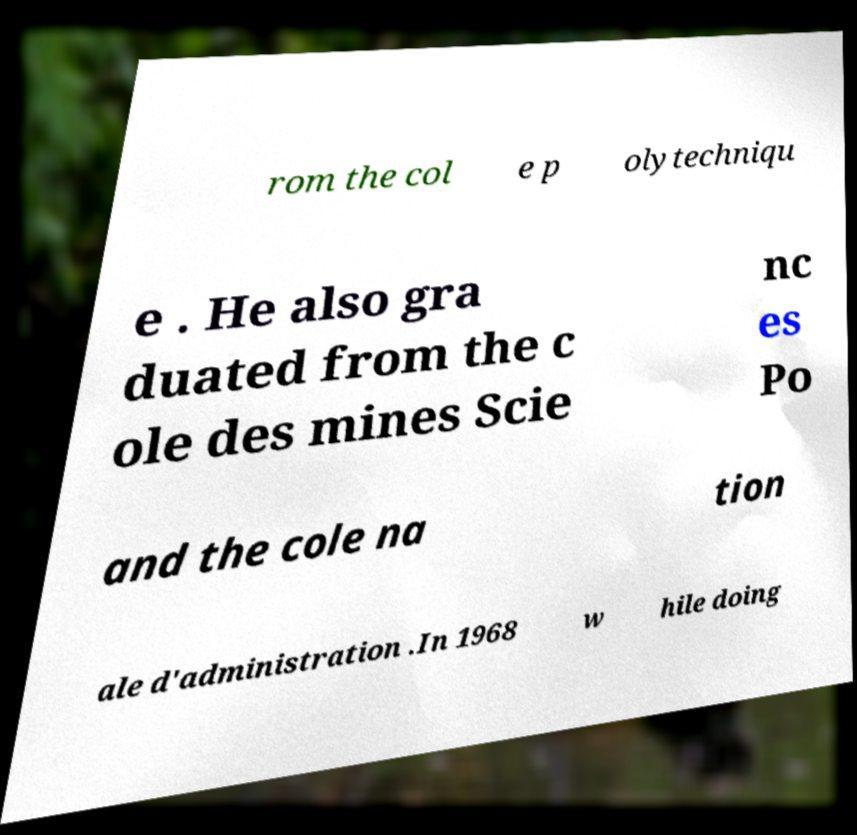What messages or text are displayed in this image? I need them in a readable, typed format. rom the col e p olytechniqu e . He also gra duated from the c ole des mines Scie nc es Po and the cole na tion ale d'administration .In 1968 w hile doing 